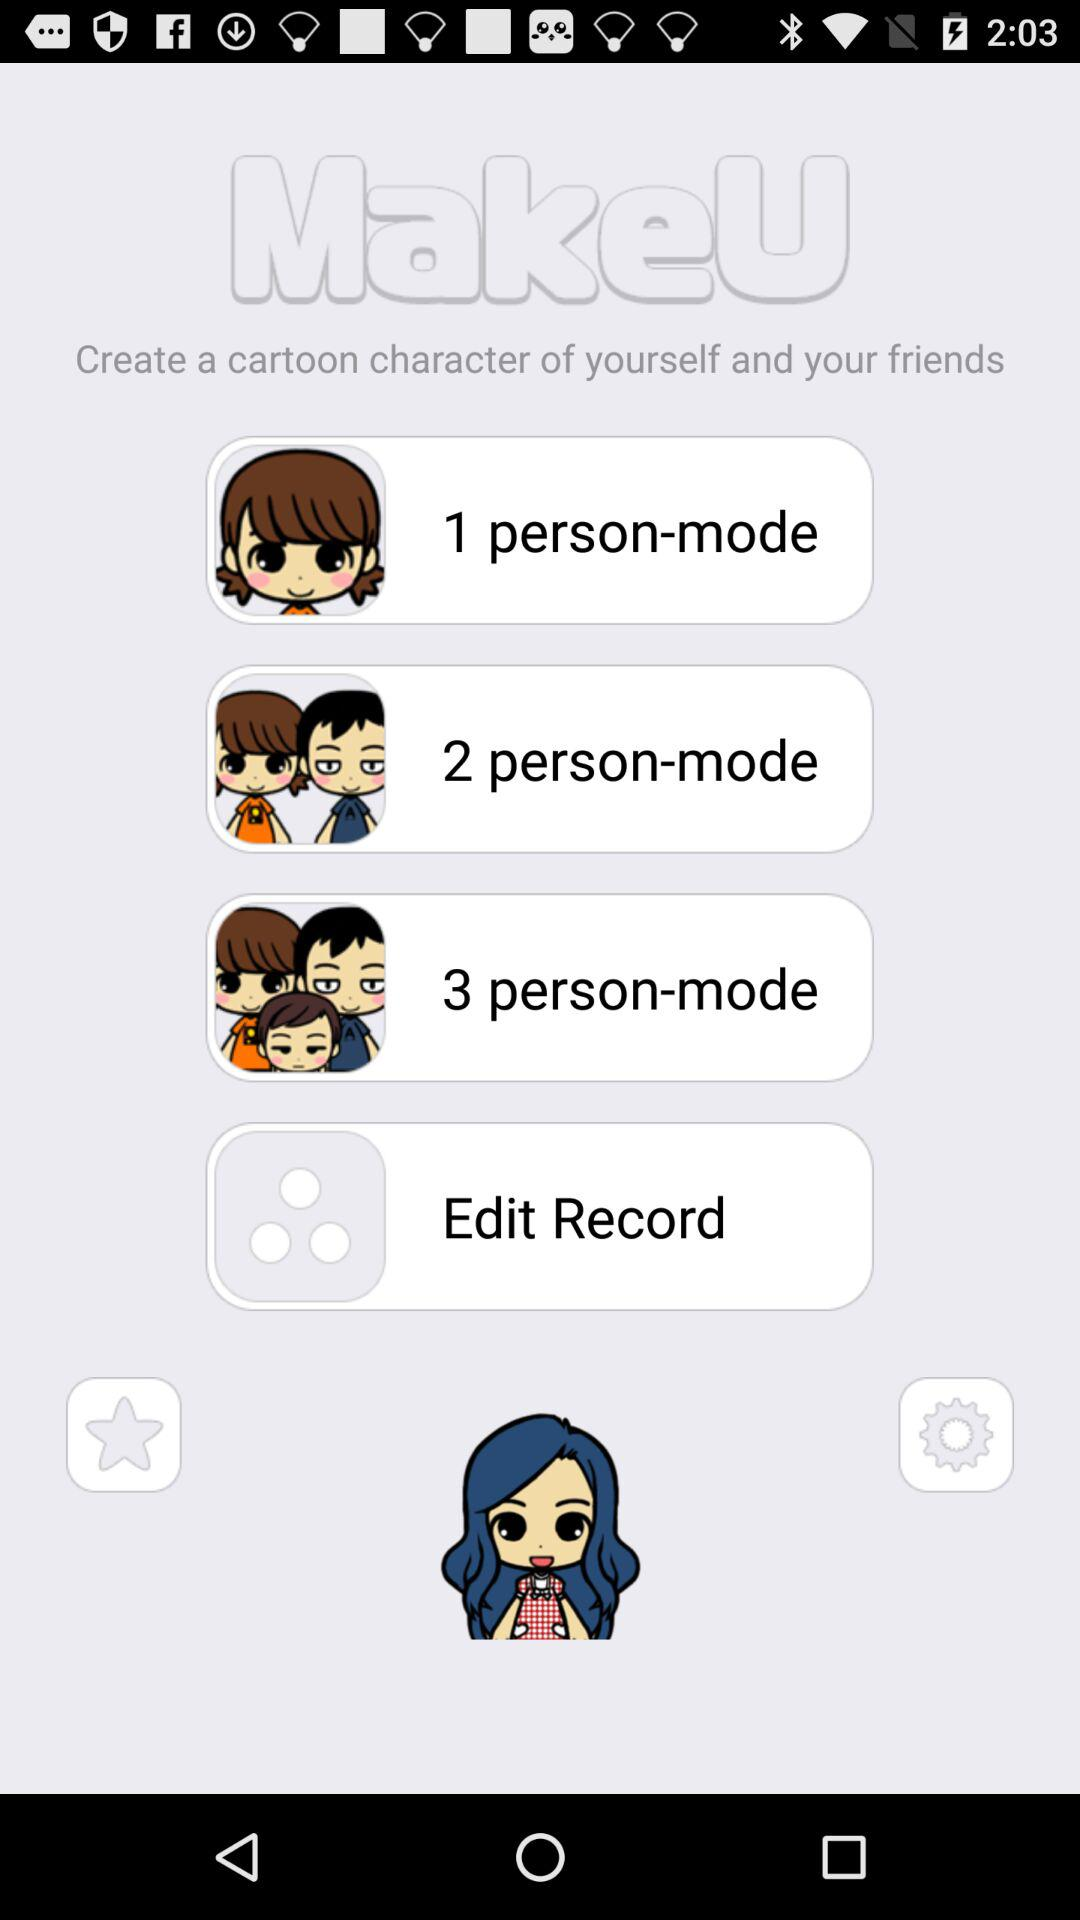Which mode is selected?
When the provided information is insufficient, respond with <no answer>. <no answer> 